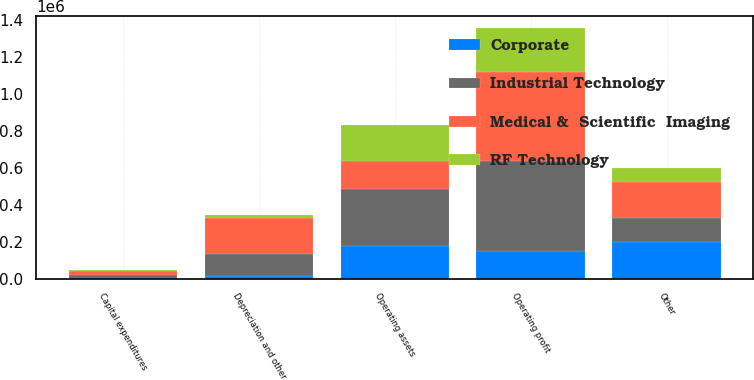Convert chart. <chart><loc_0><loc_0><loc_500><loc_500><stacked_bar_chart><ecel><fcel>Operating profit<fcel>Operating assets<fcel>Other<fcel>Capital expenditures<fcel>Depreciation and other<nl><fcel>Medical &  Scientific  Imaging<fcel>479295<fcel>151163<fcel>192041<fcel>20079<fcel>191876<nl><fcel>Industrial Technology<fcel>486575<fcel>309235<fcel>131078<fcel>18791<fcel>118643<nl><fcel>RF Technology<fcel>235018<fcel>195413<fcel>76193<fcel>5707<fcel>17109<nl><fcel>Corporate<fcel>151163<fcel>175775<fcel>196528<fcel>3155<fcel>16747<nl></chart> 